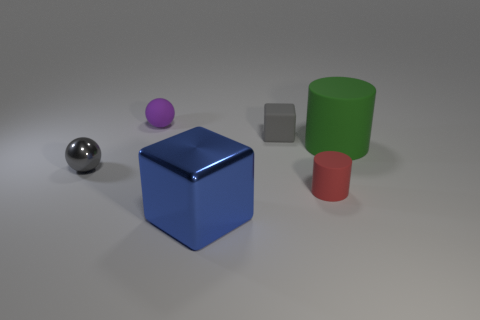Add 3 blue matte spheres. How many objects exist? 9 Subtract all spheres. How many objects are left? 4 Subtract 1 gray spheres. How many objects are left? 5 Subtract all large gray matte cubes. Subtract all small gray metal objects. How many objects are left? 5 Add 5 green cylinders. How many green cylinders are left? 6 Add 1 gray cylinders. How many gray cylinders exist? 1 